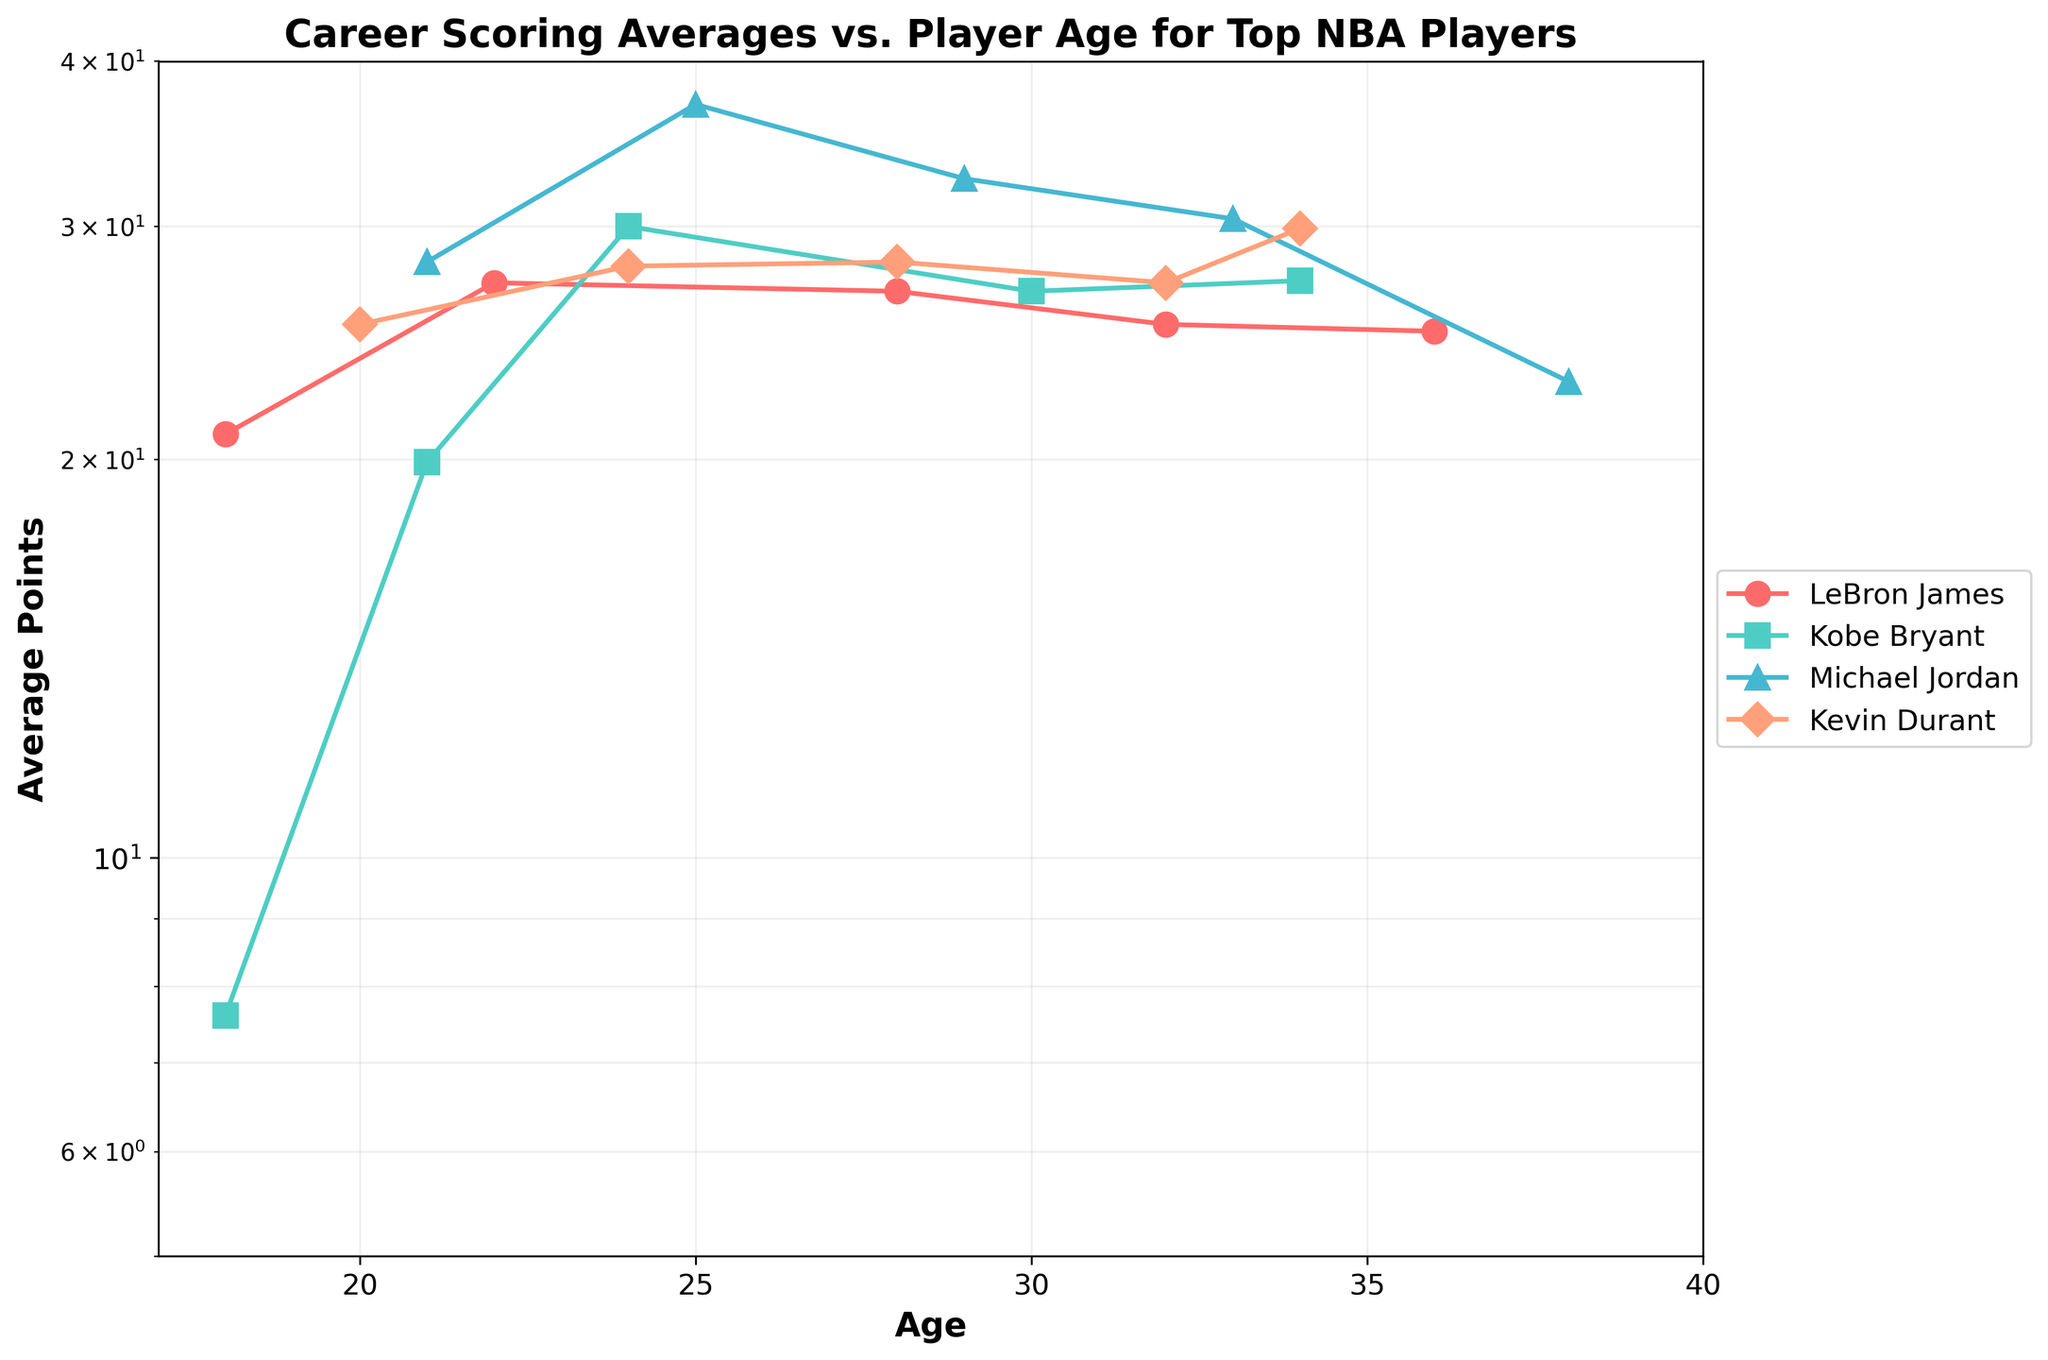Which player has the highest scoring average at age 28? From the plot, Michael Jordan at age 28 has the highest scoring average of 32.6 points among the players listed.
Answer: Michael Jordan What is the title of the plot? The title is displayed at the top of the figure.
Answer: Career Scoring Averages vs. Player Age for Top NBA Players How does the scoring trend of LeBron James change as he ages? For LeBron James, initially, his average points increase from 20.9 at age 18 to 27.2 at age 22. It then slightly decreases and stabilizes around 25 points from age 28 onwards.
Answer: Decreases slightly and stabilizes around 25 points What is the range of ages displayed on the x-axis? The bottom axis of the plot shows the age range, starting from 17 and ending at 40.
Answer: 17 to 40 Compared to Kobe Bryant, how does Kevin Durant's scoring trend differ as he ages? Kobe Bryant has a larger variation, starting low at age 18 and peaking significantly at 24. Kevin Durant maintains a more consistent scoring average, peaking slightly at 34.
Answer: Kevin Durant's trend is more consistent; Kobe Bryant's trend varies more significantly What is the scoring average for Michael Jordan at age 25? By identifying the point representing Michael Jordan at age 25 on the plot, his scoring average is 37.1.
Answer: 37.1 At which age does Kobe Bryant have his highest scoring average? Kobe Bryant has the highest peak on the plot at age 24, with an average of 30.0 points.
Answer: 24 Which player had a scoring average below 10 points? By examining the lower points of the plot, Kobe Bryant at age 18 had an average of 7.6 points.
Answer: Kobe Bryant at age 18 How does the scoring trend of Michael Jordan compare to that of LeBron James as they both reach age 32? At age 32, Michael Jordan has a higher average (30.4 points) compared to LeBron James (25.3 points).
Answer: Michael Jordan has a higher average Name all the players who have an age represented at 34 years old and their respective scoring averages. From the figure, Kobe Bryant at age 34 has 27.3 points and Kevin Durant at age 34 has 29.9 points.
Answer: Kobe Bryant: 27.3, Kevin Durant: 29.9 